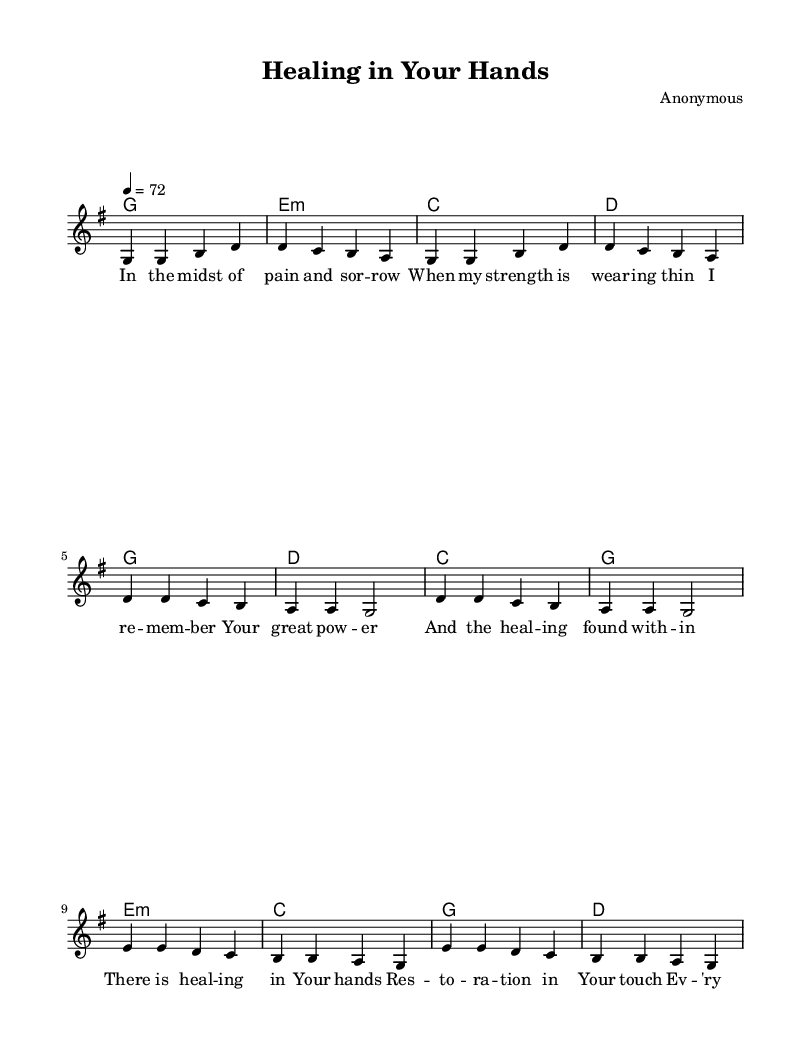What is the key signature of this music? The key signature is G major, which has one sharp (F#). This can be identified from the indicated key signature at the beginning of the sheet music.
Answer: G major What is the time signature of the piece? The time signature is 4/4, which can be seen at the beginning of the music. This indicates that there are four beats in each measure and that each quarter note gets one beat.
Answer: 4/4 What is the tempo of the piece? The tempo is marked at 72 beats per minute, as indicated by the tempo marking at the start of the music. This indicates the speed at which the piece should be played.
Answer: 72 How many verses are included in the song? There is one verse included in the song, which can be determined by looking at the structure of the piece, where only one set of verse lyrics is provided.
Answer: One What is the emotional theme of the lyrics in the chorus? The emotional theme of the chorus revolves around healing and restoration, as the lyrics express the idea of brokenness being made whole through divine love. This can be inferred from the content of the chorus lyrics.
Answer: Healing and restoration What is the function of the bridge in the song structure? The bridge serves as a contrasting section that typically introduces a new idea or emotional depth to the song. In this instance, the bridge highlights themes of comfort and faithfulness, providing a transition before returning to the chorus.
Answer: Contrast and depth What is the first note of the melody in the verse? The first note of the melody in the verse is G, which is the starting note of the melody line as shown at the beginning of the verse section.
Answer: G 